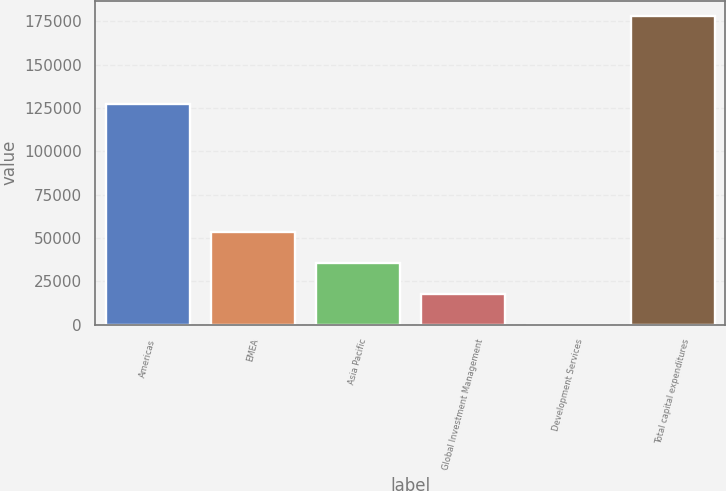Convert chart. <chart><loc_0><loc_0><loc_500><loc_500><bar_chart><fcel>Americas<fcel>EMEA<fcel>Asia Pacific<fcel>Global Investment Management<fcel>Development Services<fcel>Total capital expenditures<nl><fcel>127135<fcel>53451.1<fcel>35652.4<fcel>17853.7<fcel>55<fcel>178042<nl></chart> 